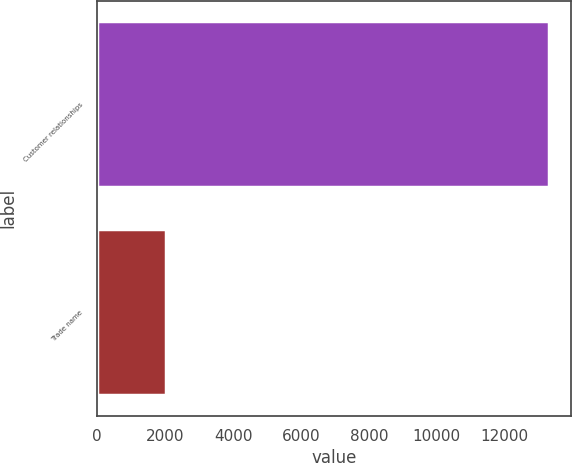<chart> <loc_0><loc_0><loc_500><loc_500><bar_chart><fcel>Customer relationships<fcel>Trade name<nl><fcel>13297<fcel>2023<nl></chart> 